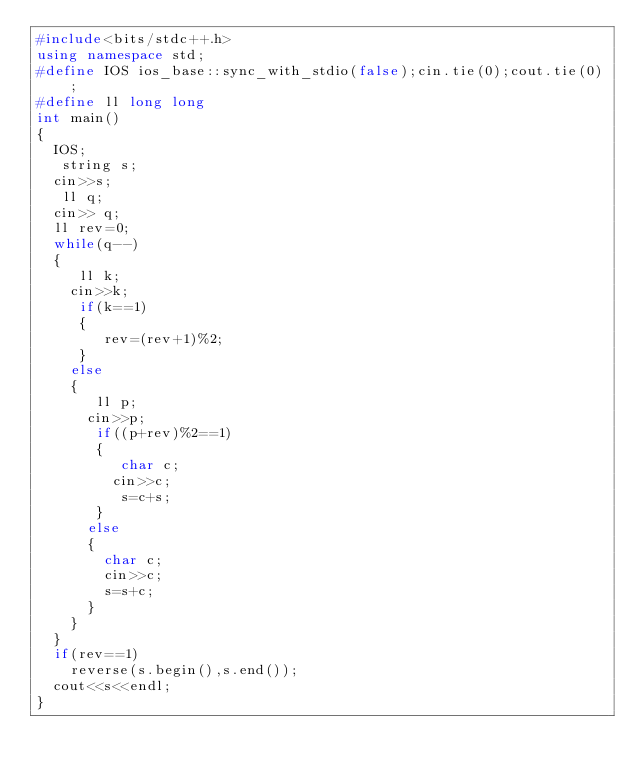Convert code to text. <code><loc_0><loc_0><loc_500><loc_500><_C++_>#include<bits/stdc++.h>
using namespace std;
#define IOS ios_base::sync_with_stdio(false);cin.tie(0);cout.tie(0);
#define ll long long
int main()
{
  IOS;
   string s;
  cin>>s;
   ll q;
  cin>> q;
  ll rev=0;
  while(q--)
  {
     ll k;
    cin>>k;
     if(k==1)
     {
        rev=(rev+1)%2;
     }
    else
    {
       ll p;
      cin>>p;
       if((p+rev)%2==1)
       {
          char c;
         cin>>c;
          s=c+s;
       }
      else
      {
        char c;
        cin>>c;
        s=s+c;
      }
    }
  }
  if(rev==1)
    reverse(s.begin(),s.end());
  cout<<s<<endl;
}</code> 